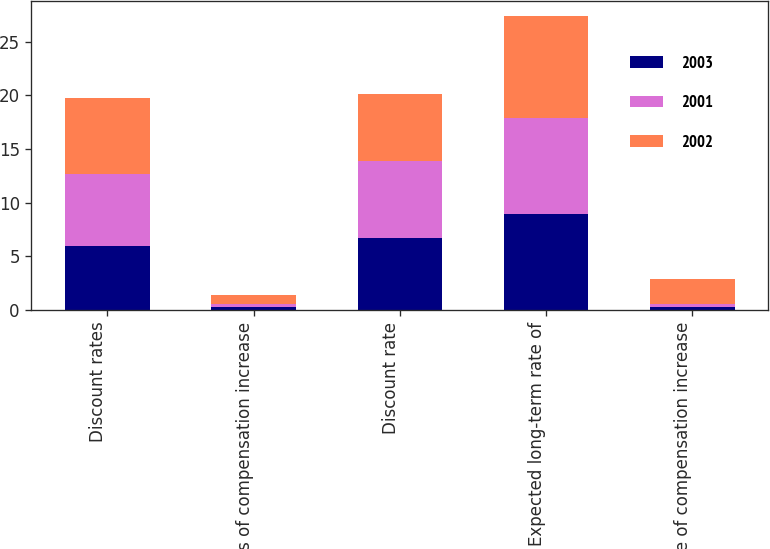Convert chart to OTSL. <chart><loc_0><loc_0><loc_500><loc_500><stacked_bar_chart><ecel><fcel>Discount rates<fcel>Rates of compensation increase<fcel>Discount rate<fcel>Expected long-term rate of<fcel>Rate of compensation increase<nl><fcel>2003<fcel>6<fcel>0.3<fcel>6.7<fcel>8.9<fcel>0.3<nl><fcel>2001<fcel>6.7<fcel>0.3<fcel>7.2<fcel>9<fcel>0.3<nl><fcel>2002<fcel>7<fcel>0.8<fcel>6.2<fcel>9.5<fcel>2.3<nl></chart> 